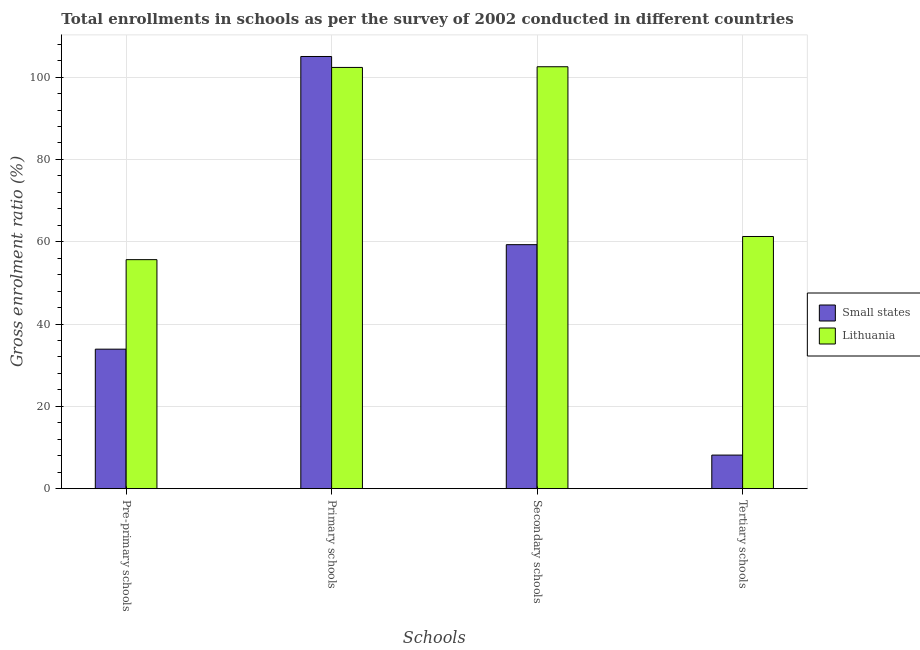How many groups of bars are there?
Provide a short and direct response. 4. How many bars are there on the 1st tick from the right?
Provide a short and direct response. 2. What is the label of the 3rd group of bars from the left?
Offer a terse response. Secondary schools. What is the gross enrolment ratio in pre-primary schools in Lithuania?
Your response must be concise. 55.65. Across all countries, what is the maximum gross enrolment ratio in secondary schools?
Make the answer very short. 102.52. Across all countries, what is the minimum gross enrolment ratio in primary schools?
Your answer should be compact. 102.35. In which country was the gross enrolment ratio in pre-primary schools maximum?
Your response must be concise. Lithuania. In which country was the gross enrolment ratio in primary schools minimum?
Make the answer very short. Lithuania. What is the total gross enrolment ratio in pre-primary schools in the graph?
Your answer should be very brief. 89.54. What is the difference between the gross enrolment ratio in pre-primary schools in Small states and that in Lithuania?
Your answer should be compact. -21.75. What is the difference between the gross enrolment ratio in secondary schools in Lithuania and the gross enrolment ratio in pre-primary schools in Small states?
Your answer should be compact. 68.62. What is the average gross enrolment ratio in pre-primary schools per country?
Your answer should be very brief. 44.77. What is the difference between the gross enrolment ratio in secondary schools and gross enrolment ratio in primary schools in Lithuania?
Keep it short and to the point. 0.17. What is the ratio of the gross enrolment ratio in pre-primary schools in Small states to that in Lithuania?
Give a very brief answer. 0.61. Is the gross enrolment ratio in tertiary schools in Small states less than that in Lithuania?
Provide a succinct answer. Yes. What is the difference between the highest and the second highest gross enrolment ratio in secondary schools?
Provide a succinct answer. 43.23. What is the difference between the highest and the lowest gross enrolment ratio in secondary schools?
Make the answer very short. 43.23. In how many countries, is the gross enrolment ratio in secondary schools greater than the average gross enrolment ratio in secondary schools taken over all countries?
Your answer should be compact. 1. What does the 2nd bar from the left in Pre-primary schools represents?
Your response must be concise. Lithuania. What does the 1st bar from the right in Secondary schools represents?
Give a very brief answer. Lithuania. Is it the case that in every country, the sum of the gross enrolment ratio in pre-primary schools and gross enrolment ratio in primary schools is greater than the gross enrolment ratio in secondary schools?
Your answer should be very brief. Yes. How many bars are there?
Offer a very short reply. 8. Does the graph contain any zero values?
Make the answer very short. No. How many legend labels are there?
Your answer should be very brief. 2. What is the title of the graph?
Ensure brevity in your answer.  Total enrollments in schools as per the survey of 2002 conducted in different countries. Does "Papua New Guinea" appear as one of the legend labels in the graph?
Ensure brevity in your answer.  No. What is the label or title of the X-axis?
Offer a terse response. Schools. What is the Gross enrolment ratio (%) of Small states in Pre-primary schools?
Give a very brief answer. 33.9. What is the Gross enrolment ratio (%) in Lithuania in Pre-primary schools?
Offer a terse response. 55.65. What is the Gross enrolment ratio (%) in Small states in Primary schools?
Your answer should be very brief. 105.01. What is the Gross enrolment ratio (%) in Lithuania in Primary schools?
Give a very brief answer. 102.35. What is the Gross enrolment ratio (%) of Small states in Secondary schools?
Provide a succinct answer. 59.29. What is the Gross enrolment ratio (%) of Lithuania in Secondary schools?
Offer a terse response. 102.52. What is the Gross enrolment ratio (%) of Small states in Tertiary schools?
Your response must be concise. 8.16. What is the Gross enrolment ratio (%) of Lithuania in Tertiary schools?
Offer a very short reply. 61.27. Across all Schools, what is the maximum Gross enrolment ratio (%) in Small states?
Make the answer very short. 105.01. Across all Schools, what is the maximum Gross enrolment ratio (%) of Lithuania?
Make the answer very short. 102.52. Across all Schools, what is the minimum Gross enrolment ratio (%) of Small states?
Provide a short and direct response. 8.16. Across all Schools, what is the minimum Gross enrolment ratio (%) in Lithuania?
Your answer should be compact. 55.65. What is the total Gross enrolment ratio (%) of Small states in the graph?
Give a very brief answer. 206.35. What is the total Gross enrolment ratio (%) of Lithuania in the graph?
Offer a terse response. 321.78. What is the difference between the Gross enrolment ratio (%) in Small states in Pre-primary schools and that in Primary schools?
Make the answer very short. -71.11. What is the difference between the Gross enrolment ratio (%) in Lithuania in Pre-primary schools and that in Primary schools?
Your answer should be very brief. -46.7. What is the difference between the Gross enrolment ratio (%) of Small states in Pre-primary schools and that in Secondary schools?
Your answer should be compact. -25.39. What is the difference between the Gross enrolment ratio (%) of Lithuania in Pre-primary schools and that in Secondary schools?
Ensure brevity in your answer.  -46.87. What is the difference between the Gross enrolment ratio (%) of Small states in Pre-primary schools and that in Tertiary schools?
Offer a very short reply. 25.73. What is the difference between the Gross enrolment ratio (%) of Lithuania in Pre-primary schools and that in Tertiary schools?
Provide a succinct answer. -5.63. What is the difference between the Gross enrolment ratio (%) of Small states in Primary schools and that in Secondary schools?
Ensure brevity in your answer.  45.72. What is the difference between the Gross enrolment ratio (%) in Lithuania in Primary schools and that in Secondary schools?
Ensure brevity in your answer.  -0.17. What is the difference between the Gross enrolment ratio (%) in Small states in Primary schools and that in Tertiary schools?
Offer a terse response. 96.85. What is the difference between the Gross enrolment ratio (%) of Lithuania in Primary schools and that in Tertiary schools?
Your answer should be very brief. 41.08. What is the difference between the Gross enrolment ratio (%) in Small states in Secondary schools and that in Tertiary schools?
Provide a succinct answer. 51.12. What is the difference between the Gross enrolment ratio (%) of Lithuania in Secondary schools and that in Tertiary schools?
Ensure brevity in your answer.  41.24. What is the difference between the Gross enrolment ratio (%) in Small states in Pre-primary schools and the Gross enrolment ratio (%) in Lithuania in Primary schools?
Keep it short and to the point. -68.45. What is the difference between the Gross enrolment ratio (%) in Small states in Pre-primary schools and the Gross enrolment ratio (%) in Lithuania in Secondary schools?
Your response must be concise. -68.62. What is the difference between the Gross enrolment ratio (%) of Small states in Pre-primary schools and the Gross enrolment ratio (%) of Lithuania in Tertiary schools?
Offer a very short reply. -27.38. What is the difference between the Gross enrolment ratio (%) of Small states in Primary schools and the Gross enrolment ratio (%) of Lithuania in Secondary schools?
Provide a short and direct response. 2.49. What is the difference between the Gross enrolment ratio (%) of Small states in Primary schools and the Gross enrolment ratio (%) of Lithuania in Tertiary schools?
Offer a very short reply. 43.74. What is the difference between the Gross enrolment ratio (%) in Small states in Secondary schools and the Gross enrolment ratio (%) in Lithuania in Tertiary schools?
Give a very brief answer. -1.99. What is the average Gross enrolment ratio (%) of Small states per Schools?
Provide a short and direct response. 51.59. What is the average Gross enrolment ratio (%) of Lithuania per Schools?
Offer a very short reply. 80.45. What is the difference between the Gross enrolment ratio (%) of Small states and Gross enrolment ratio (%) of Lithuania in Pre-primary schools?
Provide a succinct answer. -21.75. What is the difference between the Gross enrolment ratio (%) of Small states and Gross enrolment ratio (%) of Lithuania in Primary schools?
Your response must be concise. 2.66. What is the difference between the Gross enrolment ratio (%) in Small states and Gross enrolment ratio (%) in Lithuania in Secondary schools?
Your answer should be very brief. -43.23. What is the difference between the Gross enrolment ratio (%) of Small states and Gross enrolment ratio (%) of Lithuania in Tertiary schools?
Give a very brief answer. -53.11. What is the ratio of the Gross enrolment ratio (%) of Small states in Pre-primary schools to that in Primary schools?
Keep it short and to the point. 0.32. What is the ratio of the Gross enrolment ratio (%) in Lithuania in Pre-primary schools to that in Primary schools?
Give a very brief answer. 0.54. What is the ratio of the Gross enrolment ratio (%) in Small states in Pre-primary schools to that in Secondary schools?
Your answer should be very brief. 0.57. What is the ratio of the Gross enrolment ratio (%) in Lithuania in Pre-primary schools to that in Secondary schools?
Your answer should be compact. 0.54. What is the ratio of the Gross enrolment ratio (%) in Small states in Pre-primary schools to that in Tertiary schools?
Ensure brevity in your answer.  4.15. What is the ratio of the Gross enrolment ratio (%) in Lithuania in Pre-primary schools to that in Tertiary schools?
Make the answer very short. 0.91. What is the ratio of the Gross enrolment ratio (%) in Small states in Primary schools to that in Secondary schools?
Give a very brief answer. 1.77. What is the ratio of the Gross enrolment ratio (%) of Lithuania in Primary schools to that in Secondary schools?
Your answer should be very brief. 1. What is the ratio of the Gross enrolment ratio (%) of Small states in Primary schools to that in Tertiary schools?
Make the answer very short. 12.87. What is the ratio of the Gross enrolment ratio (%) of Lithuania in Primary schools to that in Tertiary schools?
Ensure brevity in your answer.  1.67. What is the ratio of the Gross enrolment ratio (%) in Small states in Secondary schools to that in Tertiary schools?
Your response must be concise. 7.26. What is the ratio of the Gross enrolment ratio (%) of Lithuania in Secondary schools to that in Tertiary schools?
Ensure brevity in your answer.  1.67. What is the difference between the highest and the second highest Gross enrolment ratio (%) of Small states?
Your answer should be compact. 45.72. What is the difference between the highest and the second highest Gross enrolment ratio (%) of Lithuania?
Make the answer very short. 0.17. What is the difference between the highest and the lowest Gross enrolment ratio (%) of Small states?
Keep it short and to the point. 96.85. What is the difference between the highest and the lowest Gross enrolment ratio (%) of Lithuania?
Provide a succinct answer. 46.87. 